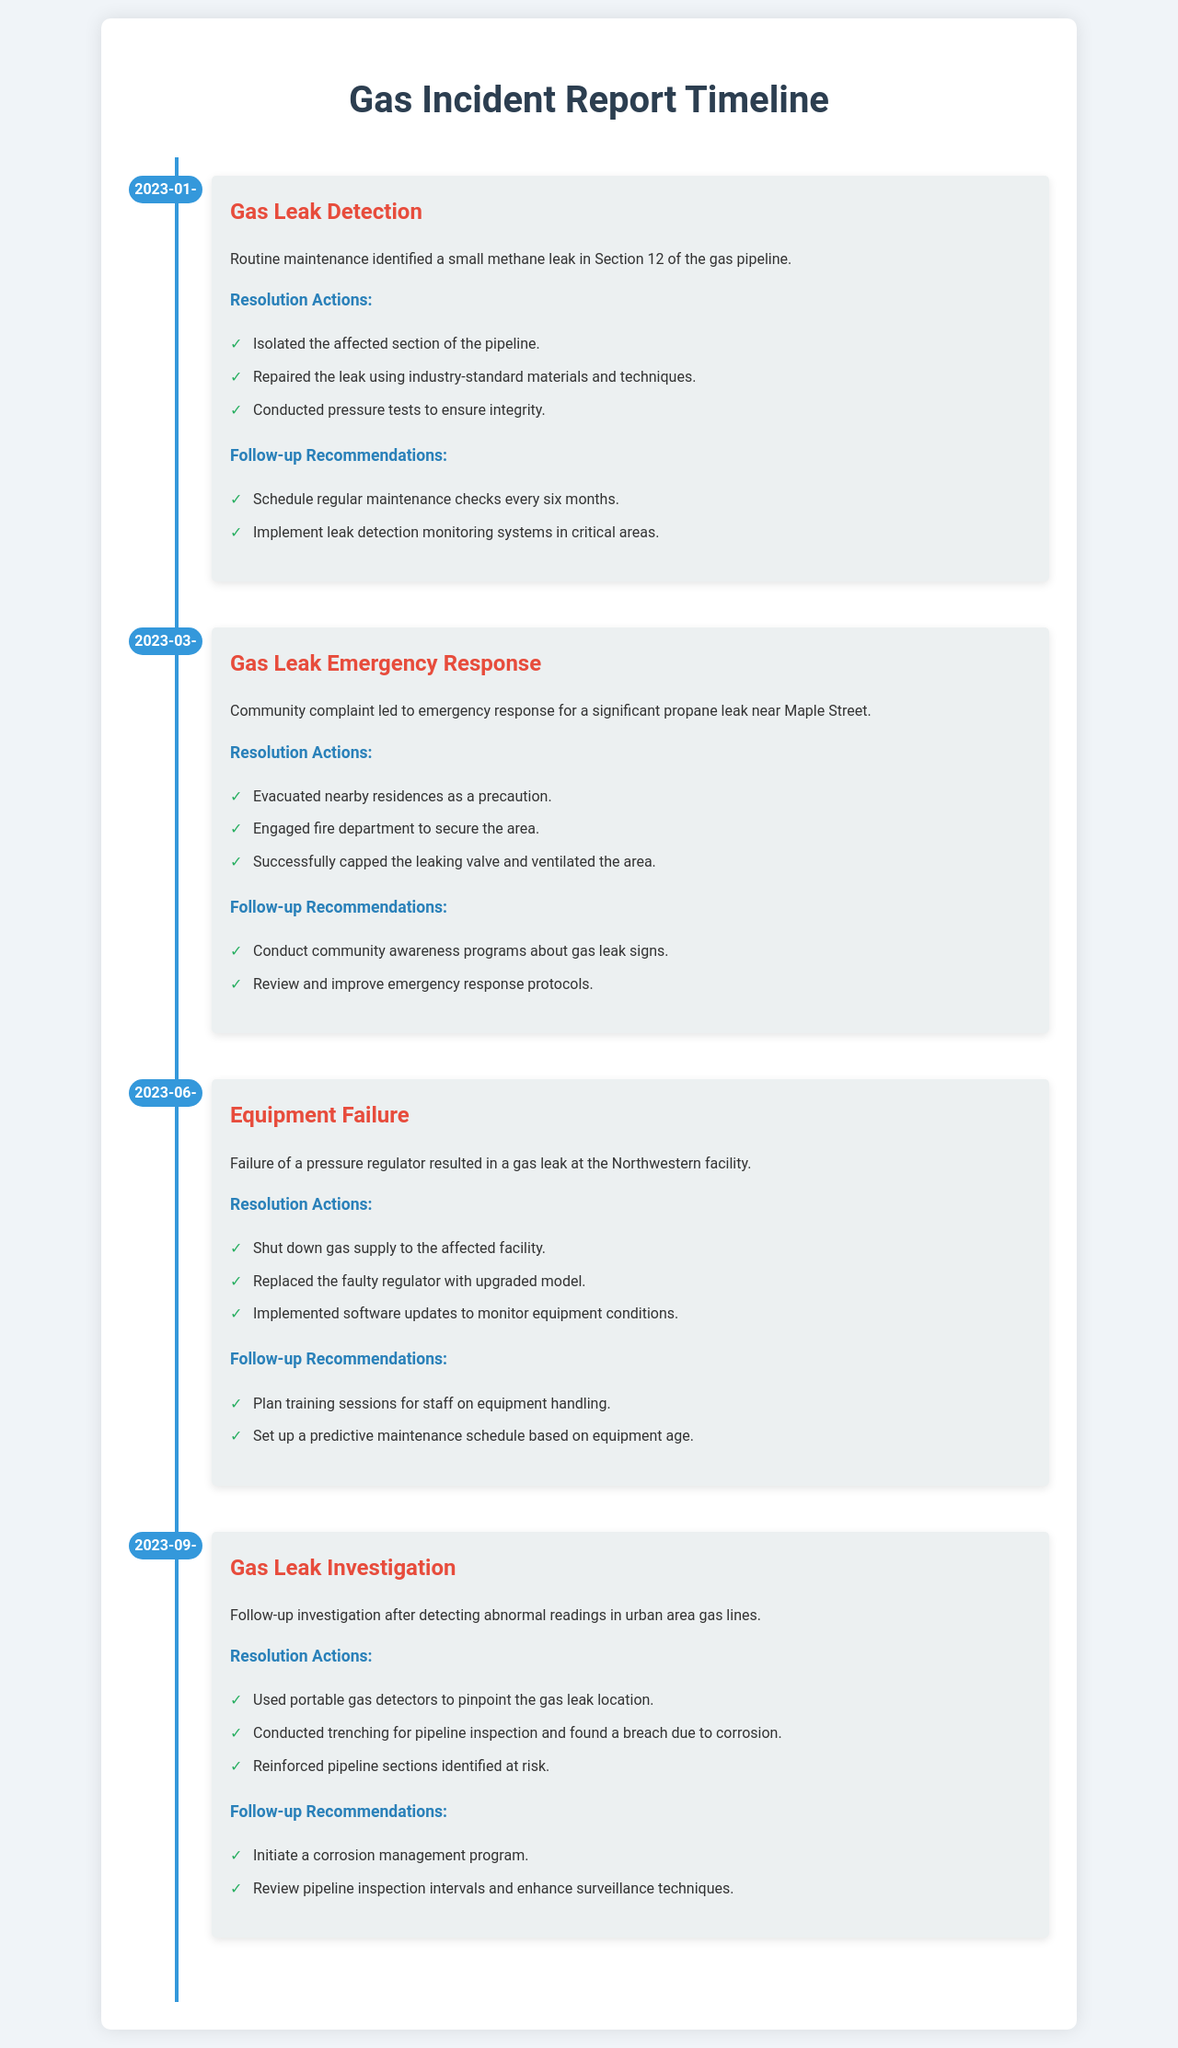What date did the gas leak detection occur? The document specifies that the gas leak detection incident occurred on January 15, 2023.
Answer: January 15, 2023 What type of incident was reported on March 20, 2023? The document states that the incident reported on March 20, 2023 was a gas leak emergency response.
Answer: Gas Leak Emergency Response How many actions were taken to resolve the gas leak identified on June 10, 2023? The resolution actions listed for the June 10, 2023 incident include three actions: shutting down gas supply, replacing the regulator, and implementing software updates.
Answer: Three What was one of the follow-up recommendations after the August 5, 2023 investigation? The follow-up recommendations include initiating a corrosion management program, as detailed for the investigation on September 5, 2023.
Answer: Initiate a corrosion management program Which facility experienced a gas leak due to equipment failure? The document indicates that the gas leak due to equipment failure occurred at the Northwestern facility.
Answer: Northwestern facility What preventive measure is recommended after the gas leak emergency response incident? The document recommends conducting community awareness programs about gas leak signs as a preventive measure after the emergency response incident.
Answer: Conduct community awareness programs about gas leak signs How many incidents are documented overall? The document contains a total of four incidents, listed in the timeline.
Answer: Four 